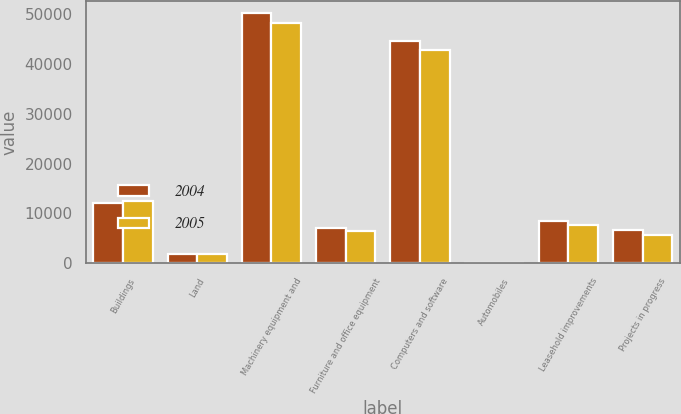Convert chart to OTSL. <chart><loc_0><loc_0><loc_500><loc_500><stacked_bar_chart><ecel><fcel>Buildings<fcel>Land<fcel>Machinery equipment and<fcel>Furniture and office equipment<fcel>Computers and software<fcel>Automobiles<fcel>Leasehold improvements<fcel>Projects in progress<nl><fcel>2004<fcel>12184<fcel>1910<fcel>50132<fcel>7090<fcel>44507<fcel>14<fcel>8449<fcel>6589<nl><fcel>2005<fcel>12510<fcel>1910<fcel>48241<fcel>6525<fcel>42690<fcel>73<fcel>7658<fcel>5608<nl></chart> 